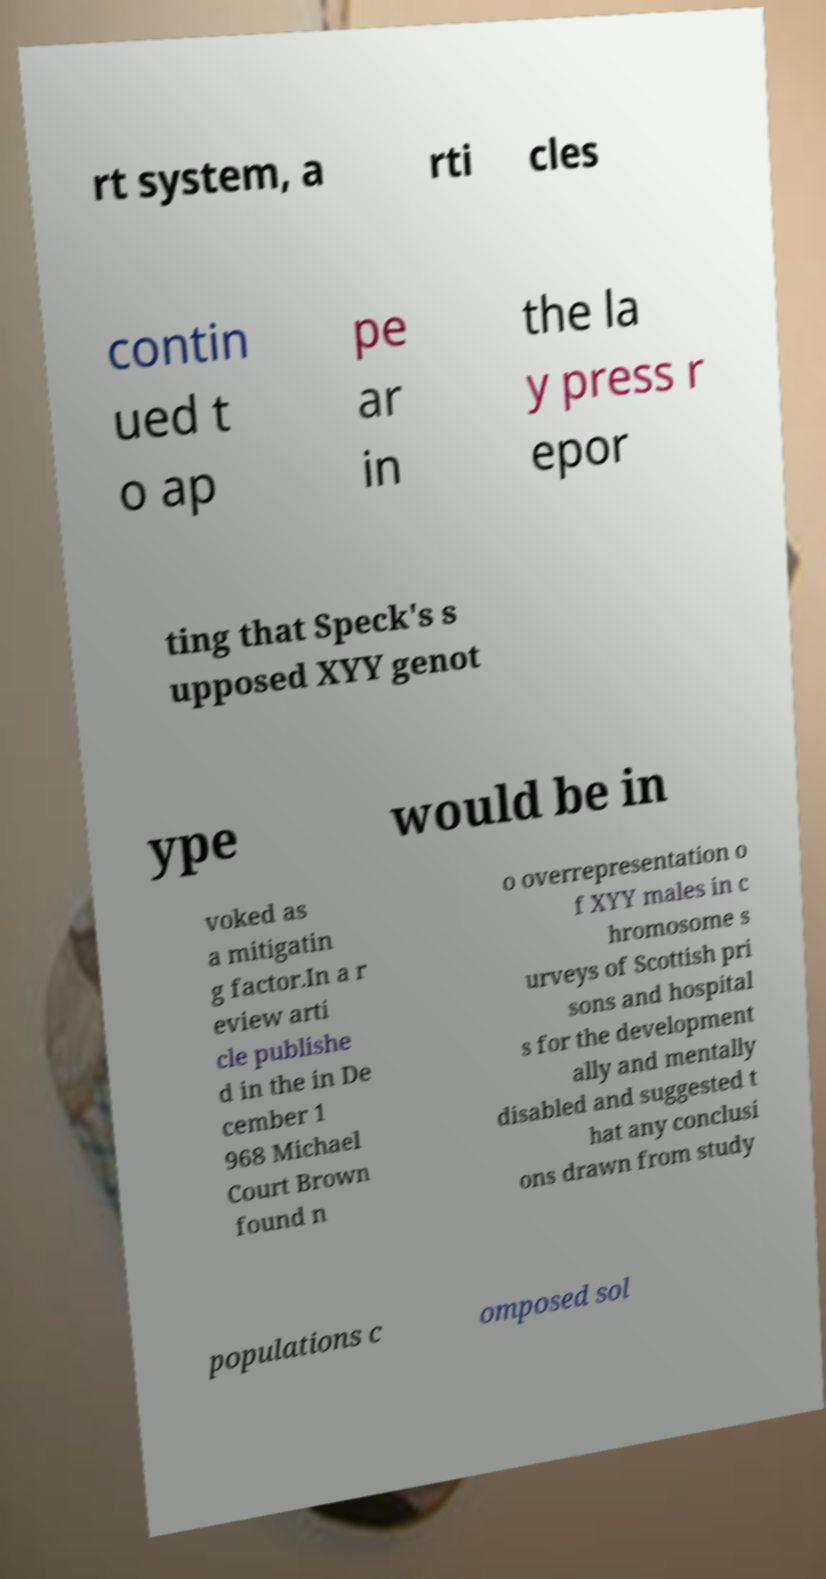Please read and relay the text visible in this image. What does it say? rt system, a rti cles contin ued t o ap pe ar in the la y press r epor ting that Speck's s upposed XYY genot ype would be in voked as a mitigatin g factor.In a r eview arti cle publishe d in the in De cember 1 968 Michael Court Brown found n o overrepresentation o f XYY males in c hromosome s urveys of Scottish pri sons and hospital s for the development ally and mentally disabled and suggested t hat any conclusi ons drawn from study populations c omposed sol 